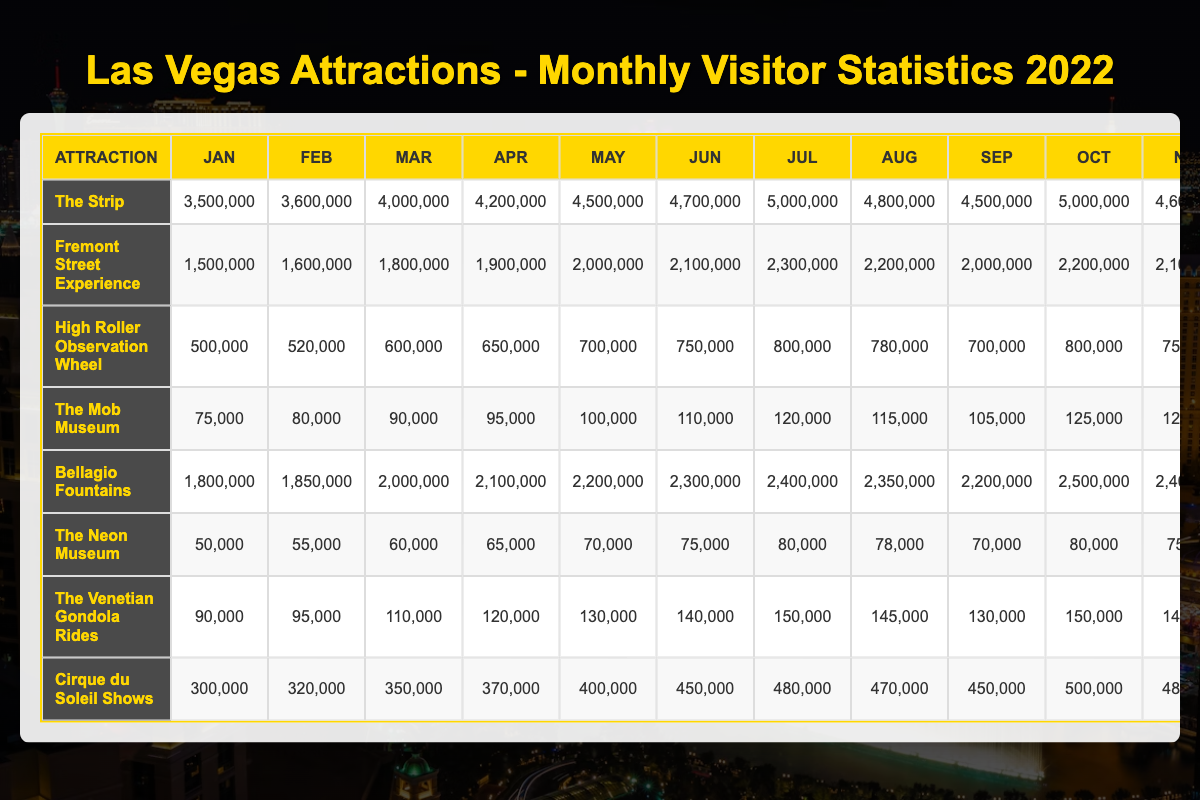What is the highest number of visitors to "The Strip" in a single month in 2022? The table shows the monthly visitors to "The Strip" for each month. By reviewing the values, the maximum occurs in December with 5,500,000 visitors.
Answer: 5,500,000 Which attraction had the least visitors in January 2022? In January, the visitor counts for each attraction are: The Strip (3,500,000), Fremont Street Experience (1,500,000), High Roller Observation Wheel (500,000), The Mob Museum (75,000), Bellagio Fountains (1,800,000), The Neon Museum (50,000), The Venetian Gondola Rides (90,000), Cirque du Soleil Shows (300,000). "The Neon Museum" had the least with 50,000 visitors.
Answer: The Neon Museum What is the total number of visitors to the Bellagio Fountains for the first half of 2022? The visitor counts for the Bellagio Fountains in the first half (January to June) are: 1,800,000 + 1,850,000 + 2,000,000 + 2,100,000 + 2,200,000 + 2,300,000 = 12,250,000.
Answer: 12,250,000 Was there a month in 2022 when the High Roller Observation Wheel had more than 600,000 visitors? Checking the monthly visitor count for the High Roller: January (500,000), February (520,000), March (600,000), April (650,000), May (700,000), June (750,000), July (800,000), August (780,000), September (700,000), October (800,000), November (750,000), December (900,000). Yes, starting from April, it exceeded 600,000 visitors.
Answer: Yes What was the average number of visitors per month for The Mob Museum over the entire year? The Mob Museum had the following monthly visitor counts: 75,000, 80,000, 90,000, 95,000, 100,000, 110,000, 120,000, 115,000, 105,000, 125,000, 120,000, 150,000. The total across all months is 1,335,000. There are 12 months, so the average is 1,335,000 / 12 = 111,250.
Answer: 111,250 Which attraction had a greater number of visitors in July than in August, and by how many? Checking July and August for each attraction: The Strip (5,000,000 vs. 4,800,000, difference: 200,000), Fremont Street Experience (2,300,000 vs. 2,200,000, difference: 100,000), High Roller Observation Wheel (800,000 vs. 780,000, difference: 20,000), The Mob Museum (120,000 vs. 115,000, difference: 5,000), Bellagio Fountains (2,400,000 vs. 2,350,000, difference: 50,000), The Neon Museum (80,000 vs. 78,000, difference: 2,000), The Venetian Gondola Rides (150,000 vs. 145,000, difference: 5,000), Cirque du Soleil Shows (480,000 vs. 470,000, difference: 10,000). All had more visitors in July. The largest difference is for The Strip (200,000).
Answer: The Strip, 200,000 How many visitors did the Fremont Street Experience have in the second half of 2022? The counts for Fremont Street Experience from July to December are: 2,300,000 + 2,200,000 + 2,000,000 + 2,200,000 + 2,100,000 + 2,500,000 = 12,300,000 visitors.
Answer: 12,300,000 